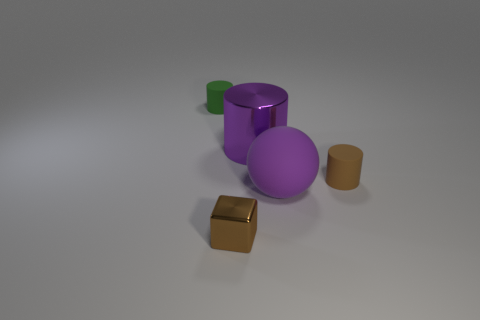Add 1 large blue metallic cubes. How many objects exist? 6 Add 5 small objects. How many small objects exist? 8 Subtract 0 cyan cubes. How many objects are left? 5 Subtract all blocks. How many objects are left? 4 Subtract all tiny gray metallic balls. Subtract all tiny brown metallic blocks. How many objects are left? 4 Add 3 small brown blocks. How many small brown blocks are left? 4 